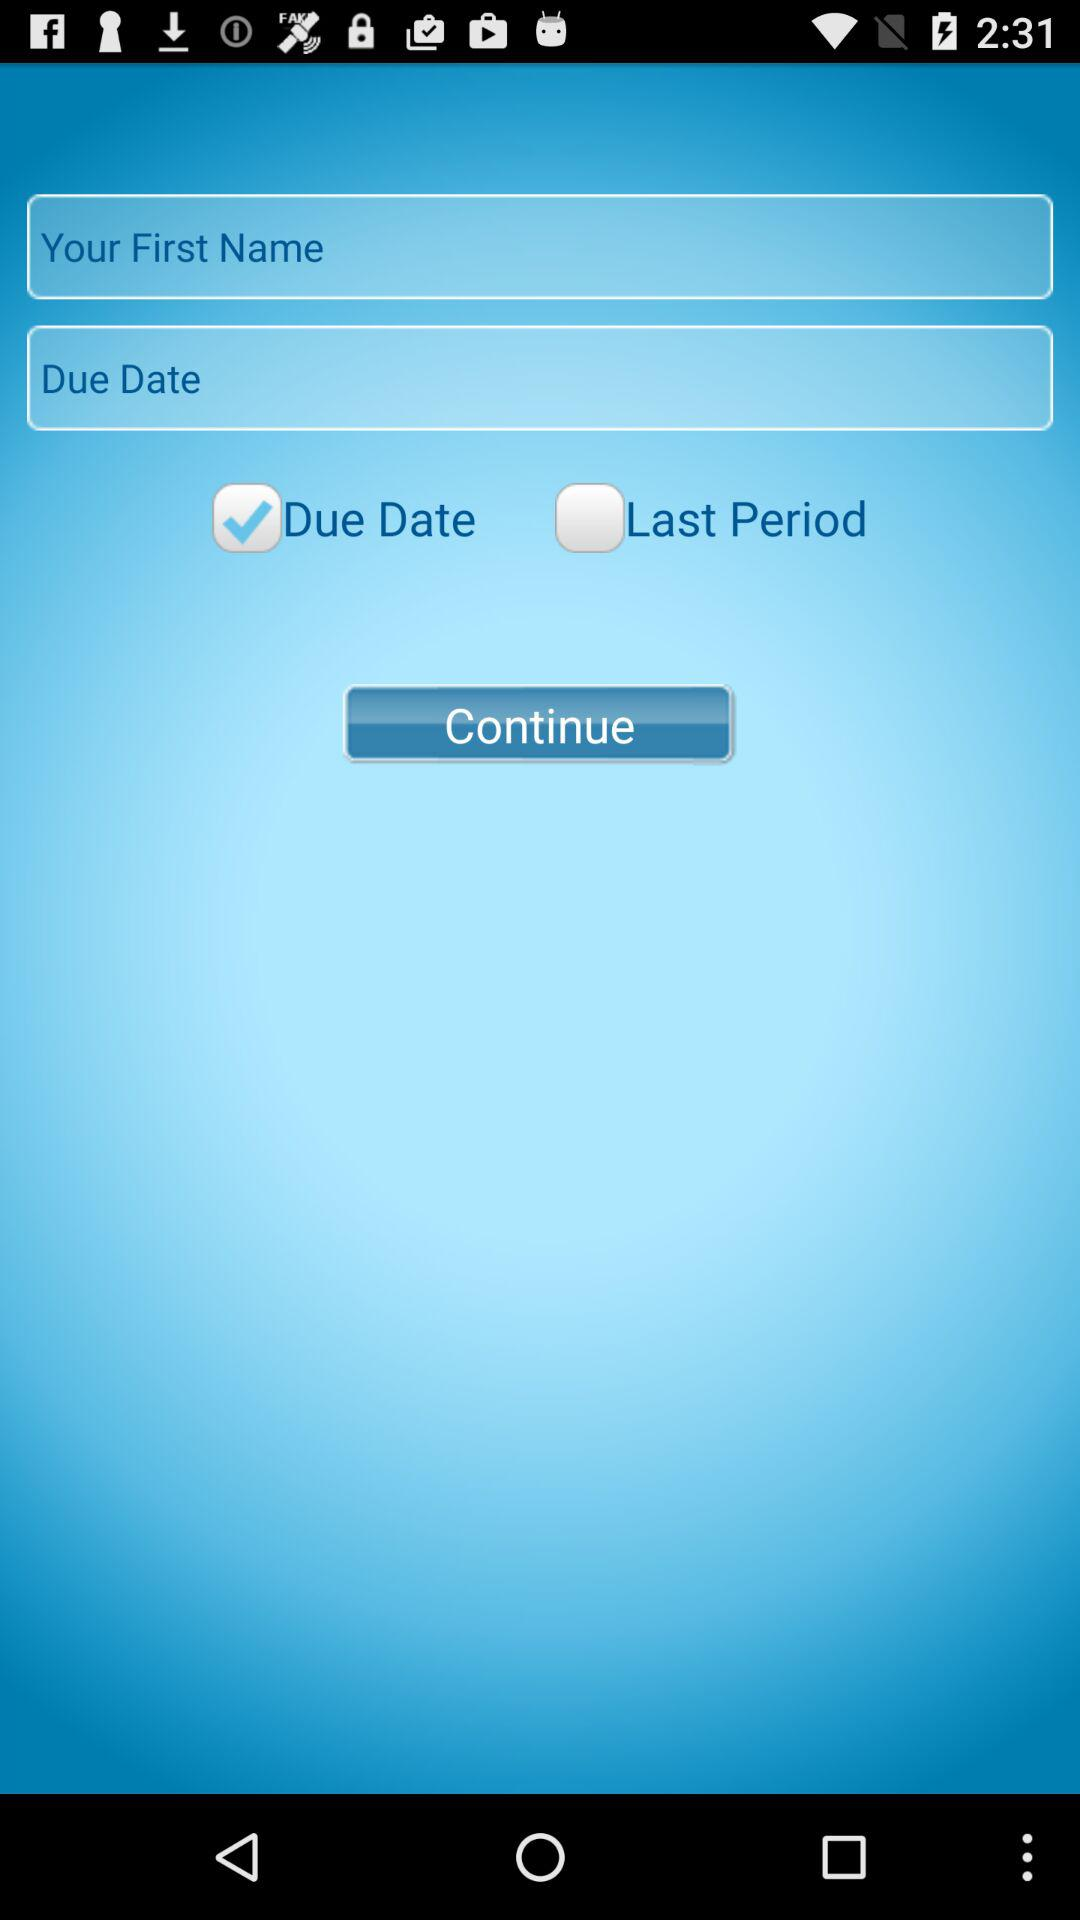How many check boxes are there on this screen?
Answer the question using a single word or phrase. 2 